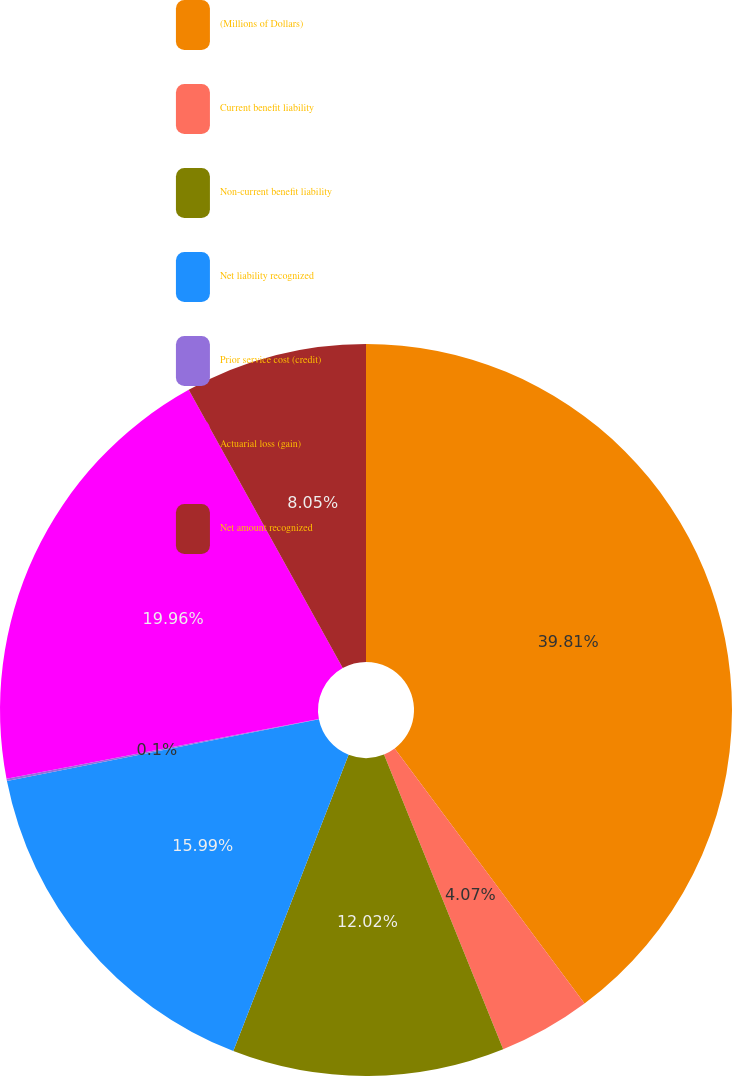Convert chart to OTSL. <chart><loc_0><loc_0><loc_500><loc_500><pie_chart><fcel>(Millions of Dollars)<fcel>Current benefit liability<fcel>Non-current benefit liability<fcel>Net liability recognized<fcel>Prior service cost (credit)<fcel>Actuarial loss (gain)<fcel>Net amount recognized<nl><fcel>39.82%<fcel>4.07%<fcel>12.02%<fcel>15.99%<fcel>0.1%<fcel>19.96%<fcel>8.05%<nl></chart> 